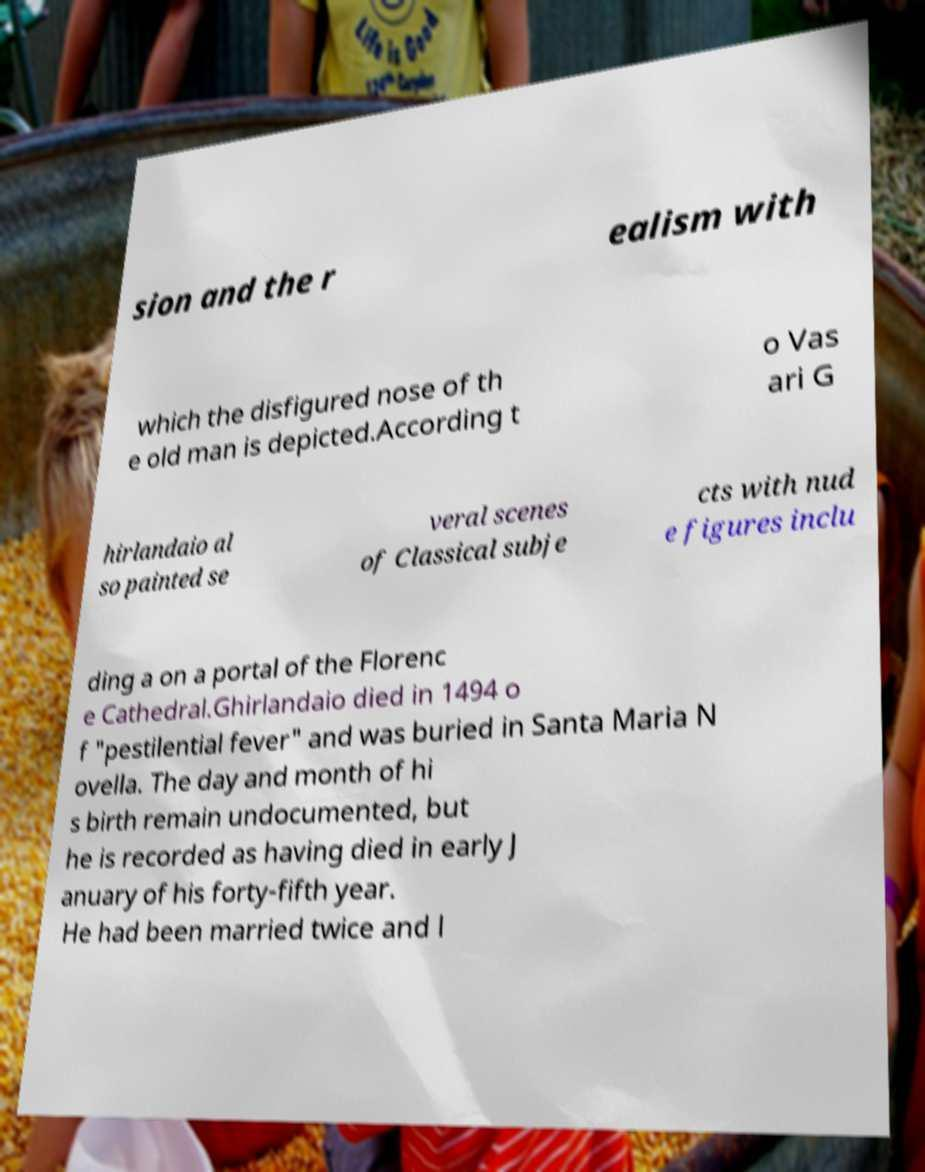Could you assist in decoding the text presented in this image and type it out clearly? sion and the r ealism with which the disfigured nose of th e old man is depicted.According t o Vas ari G hirlandaio al so painted se veral scenes of Classical subje cts with nud e figures inclu ding a on a portal of the Florenc e Cathedral.Ghirlandaio died in 1494 o f "pestilential fever" and was buried in Santa Maria N ovella. The day and month of hi s birth remain undocumented, but he is recorded as having died in early J anuary of his forty-fifth year. He had been married twice and l 